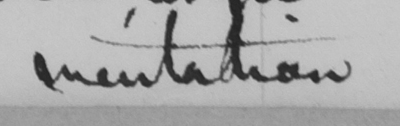Please provide the text content of this handwritten line. imitation 